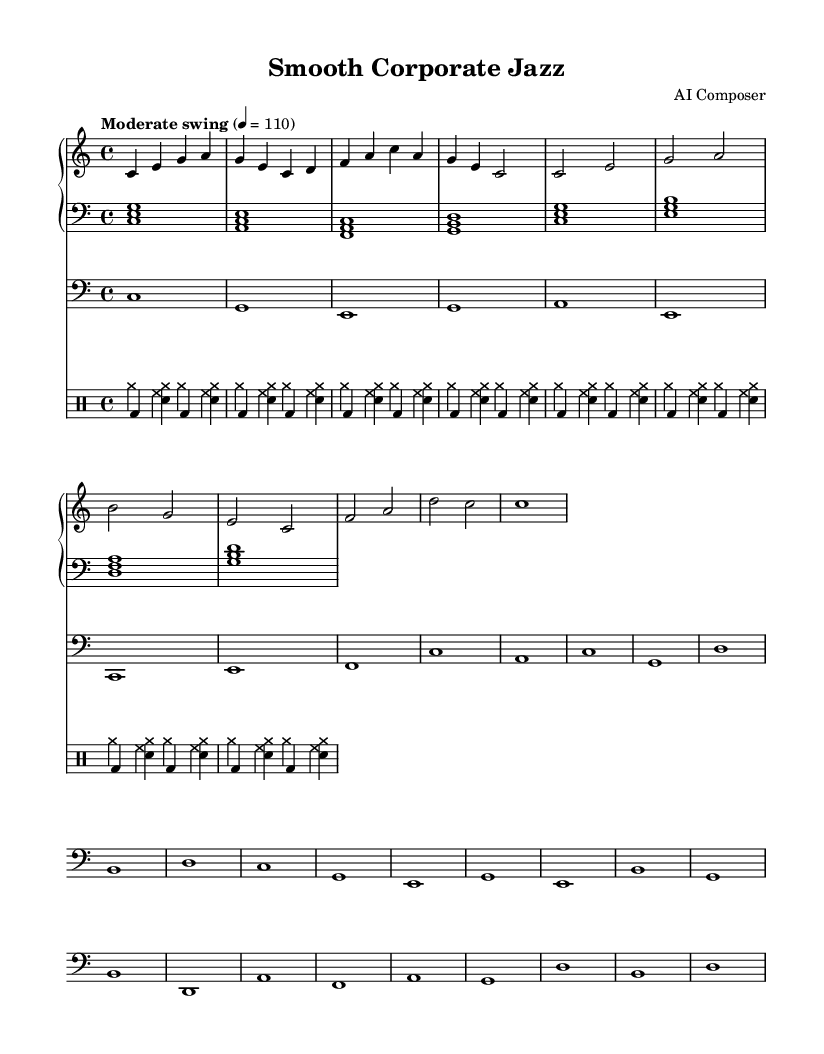What is the key signature of this music? The key signature is C major, which has no sharps or flats.
Answer: C major What is the time signature of the piece? The time signature is 4/4, indicating four beats per measure.
Answer: 4/4 What is the tempo marking given in the sheet music? The tempo marking states "Moderate swing" with a speed of quarter note equals 110 beats per minute.
Answer: Moderate swing How many measures are there in the melody for the piano right hand? By counting the measures in the right hand part, there are a total of 8 measures.
Answer: 8 measures What instrument plays the bass part? The bass part is written in the bass clef, indicating it is played on a bass instrument such as a double bass or electric bass.
Answer: Bass What rhythmic pattern is used in the drum part? The drum part alternates between cymbals and snare hits followed by bass and hi-hat hits, creating a typical swing feel.
Answer: Swing pattern Which instruments are included in this sheet music? The instruments in the score include piano (right and left hands), bass, and drums.
Answer: Piano, bass, and drums 